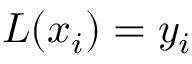<formula> <loc_0><loc_0><loc_500><loc_500>L ( x _ { i } ) = y _ { i }</formula> 